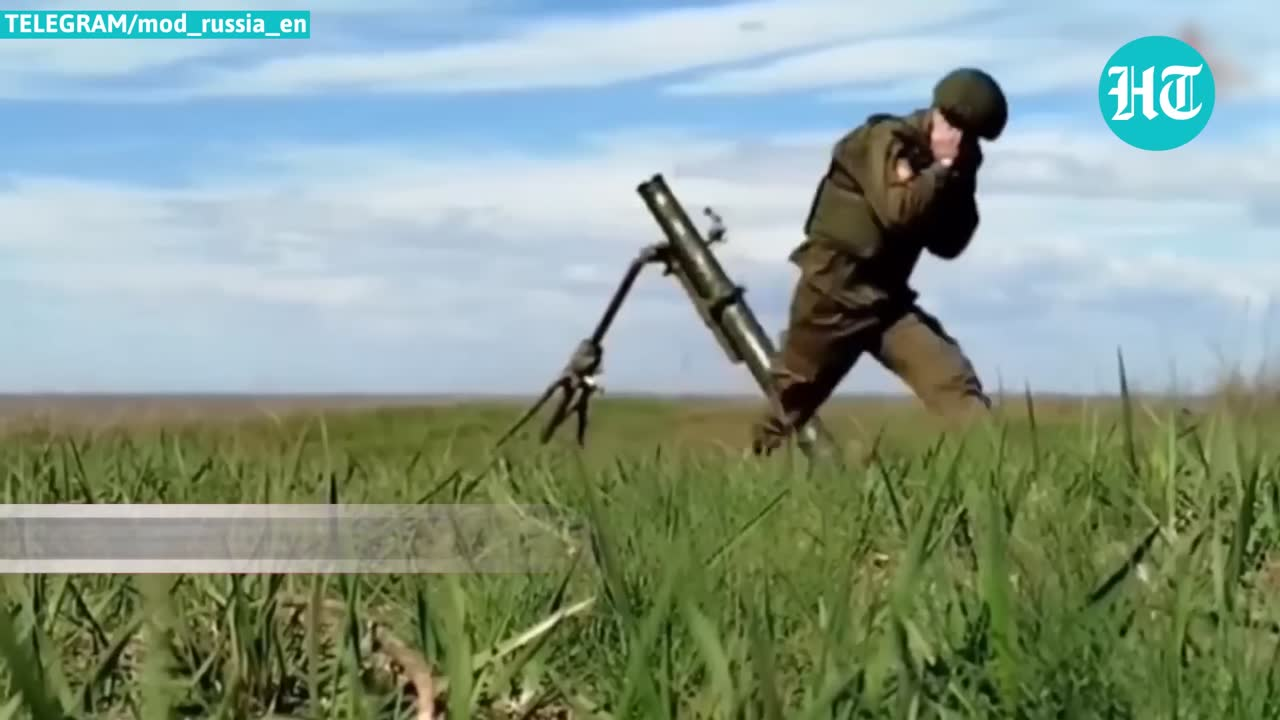describe the img The image depicts a soldier in military attire operating a mortar in an open field. The soldier is shown in a dynamic pose, appearing to be in the process of firing the mortar. They are wearing a helmet and standard military uniform. The mortar is positioned on a tripod stand, and the scene is set against a backdrop of open sky and grassy terrain. There is a watermark in the top left corner that reads "TELEGRAM/mod_russia_en" and a logo in the top right corner with the letters "HT" within a turquoise circle. 